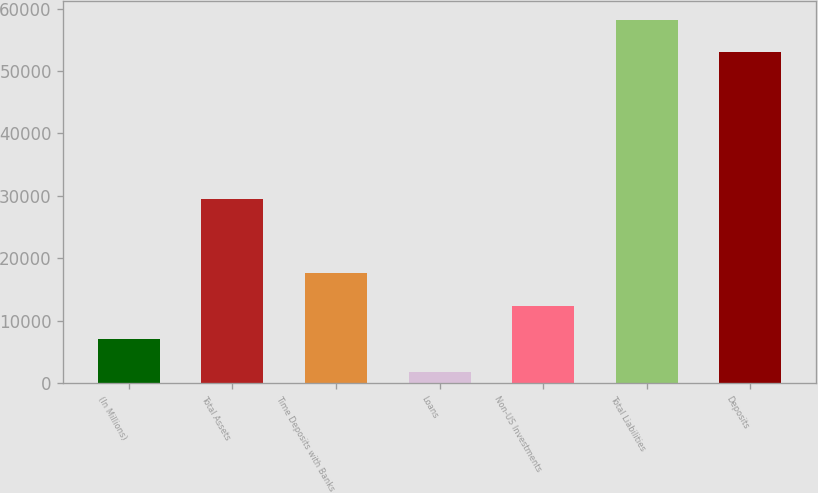<chart> <loc_0><loc_0><loc_500><loc_500><bar_chart><fcel>(In Millions)<fcel>Total Assets<fcel>Time Deposits with Banks<fcel>Loans<fcel>Non-US Investments<fcel>Total Liabilities<fcel>Deposits<nl><fcel>7035.56<fcel>29411.2<fcel>17587.9<fcel>1759.4<fcel>12311.7<fcel>58257.4<fcel>52981.2<nl></chart> 